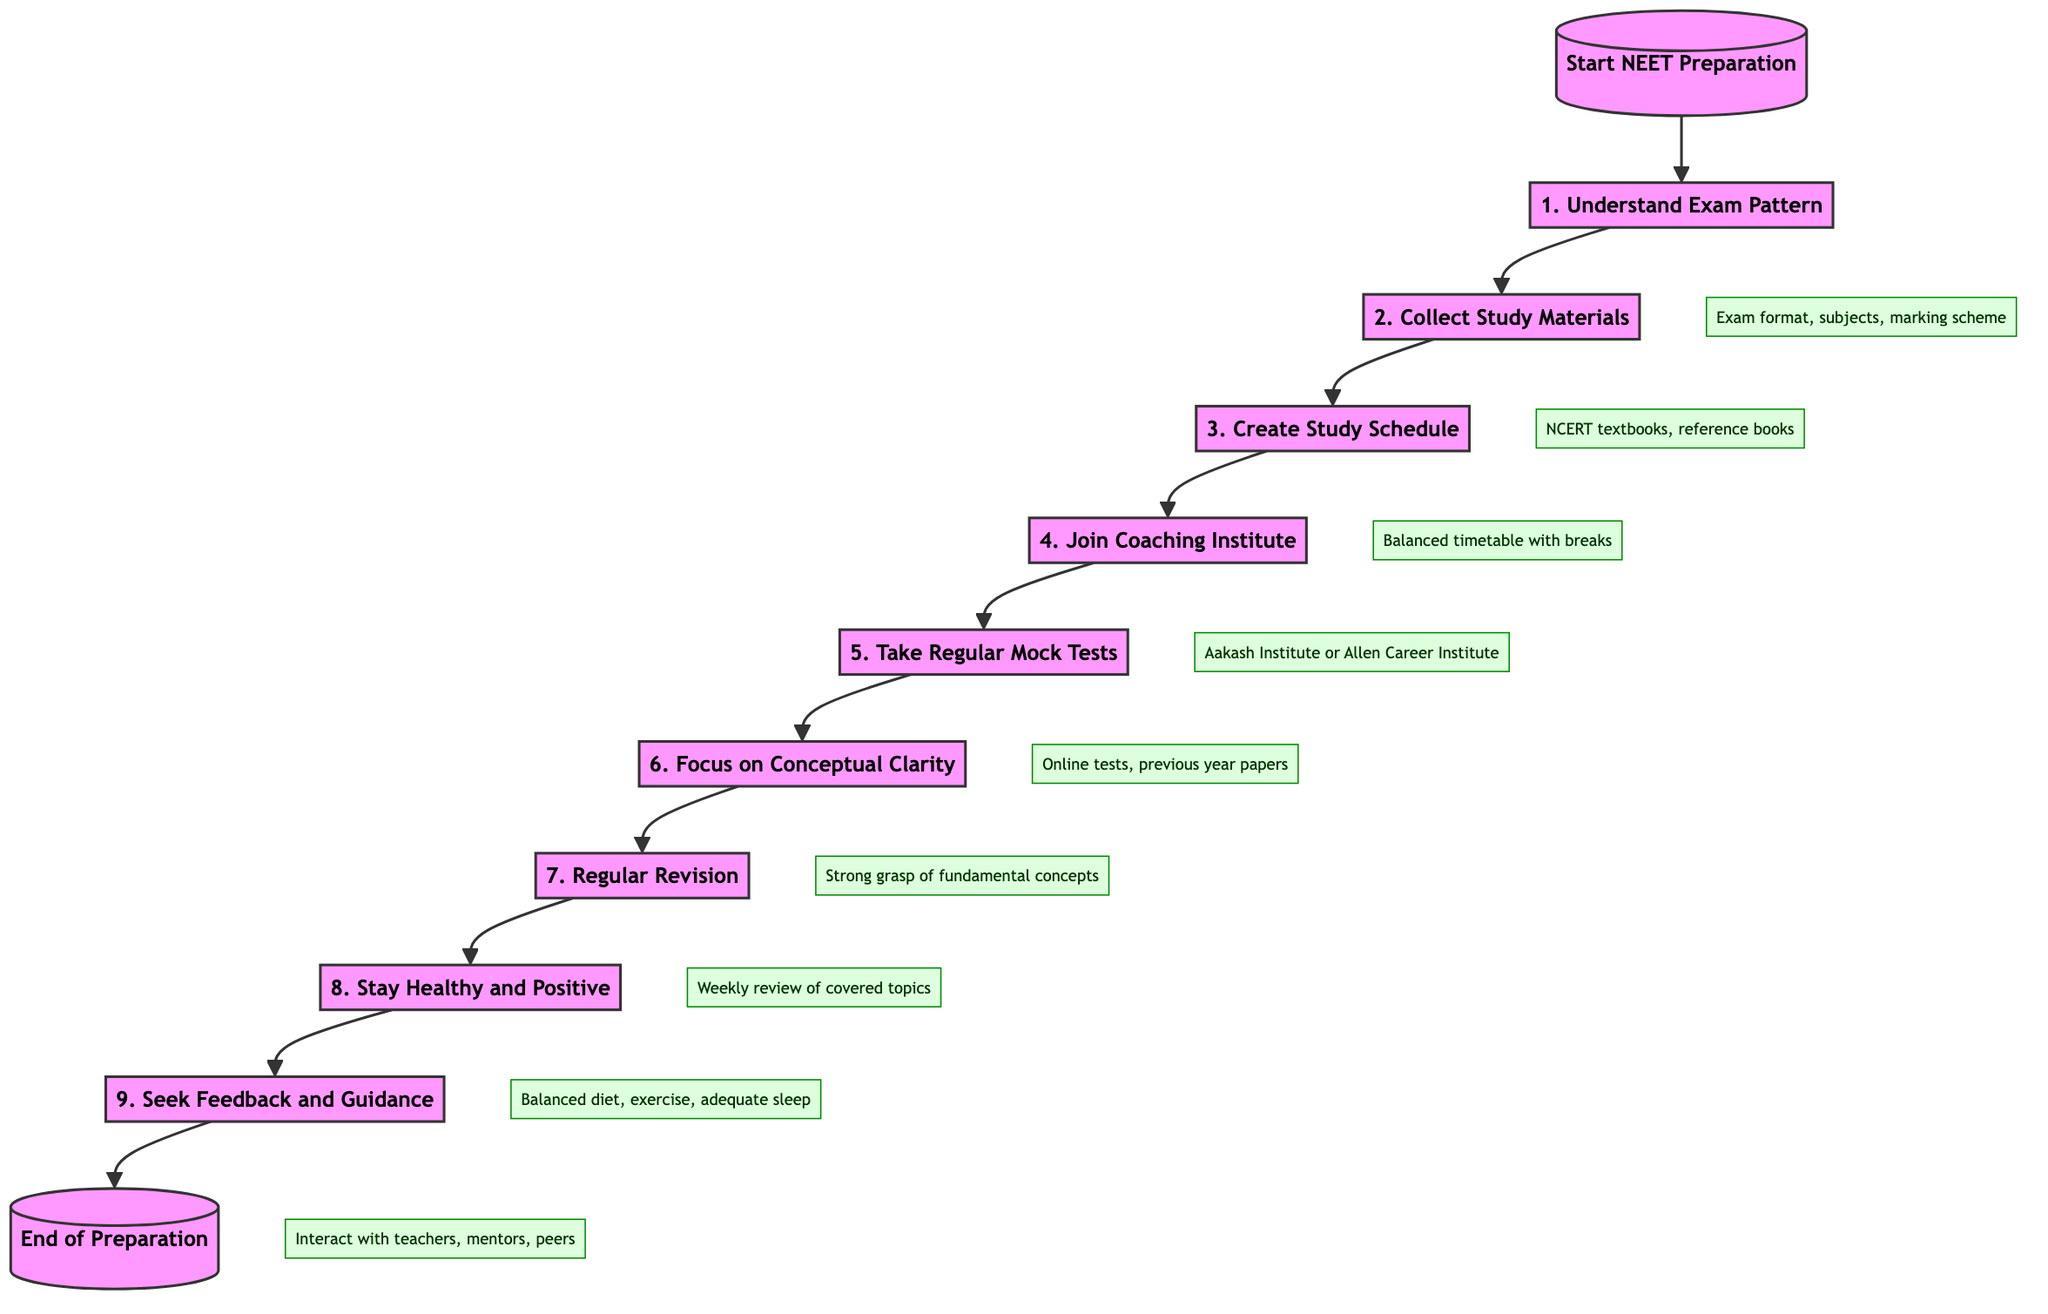What is the first step in the preparation for the NEET exam? The flowchart starts with "Understand the NEET Exam Pattern," which indicates this is the initial action to take.
Answer: Understand the NEET Exam Pattern How many steps are outlined in the preparation process? By counting the steps in the flowchart, there are a total of nine distinct steps leading to the preparation for the NEET exam.
Answer: 9 What does the third step entail? Referring to the diagram, the third step is "Create a Study Schedule," where a balanced timetable is to be developed for studying.
Answer: Create a Study Schedule Which step suggests interacting with peers for feedback? The ninth step in the flowchart states "Seek Feedback and Guidance," indicating a focus on interacting with others for evaluation of preparation strategies.
Answer: Seek Feedback and Guidance Why is taking regular mock tests important? The fifth step, "Take Regular Mock Tests," aims to build exam temperament, manage time, and identify weaknesses, thereby emphasizing its importance in effective preparation.
Answer: Manage time efficiently Which resource is recommended for Physics in step two? In the second step of the diagram, it is stated to gather "H.C. Verma" as a reference book for Physics alongside NCERT textbooks.
Answer: H.C. Verma What should you focus on according to the sixth step? The sixth step instructs to focus on "Conceptual Clarity," stressing the understanding of fundamental concepts rather than memorization alone.
Answer: Conceptual Clarity What is advised in the eighth step to maintain well-being? The eighth step emphasizes the importance of maintaining "a balanced diet, exercise regularly, and ensure adequate sleep" to remain healthy during preparation.
Answer: Balanced diet, exercise, adequate sleep Which step involves enrolling in a coaching institute? The fourth step of the flowchart discusses the importance of "Join a Coaching Institute" for structured guidance during preparation.
Answer: Join a Coaching Institute 